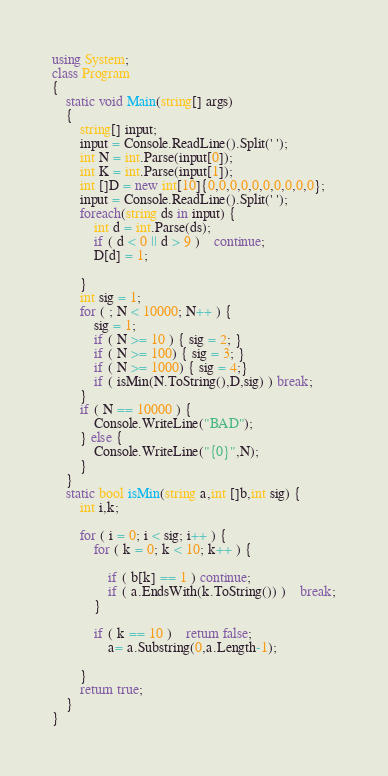<code> <loc_0><loc_0><loc_500><loc_500><_C#_>using System;
class Program
{
	static void Main(string[] args)
	{
		string[] input;
		input = Console.ReadLine().Split(' ');
		int N = int.Parse(input[0]);
		int K = int.Parse(input[1]);
		int []D = new int[10]{0,0,0,0,0,0,0,0,0,0};
		input = Console.ReadLine().Split(' ');
		foreach(string ds in input) {
			int d = int.Parse(ds);
			if ( d < 0 || d > 9 )	continue;
			D[d] = 1;

		}
		int sig = 1;
		for ( ; N < 10000; N++ ) {
			sig = 1;
			if ( N >= 10 ) { sig = 2; }
			if ( N >= 100) { sig = 3; }	
			if ( N >= 1000) { sig = 4;}
			if ( isMin(N.ToString(),D,sig) ) break;
		}
		if ( N == 10000 ) {
			Console.WriteLine("BAD");
		} else {
			Console.WriteLine("{0}",N);
		}
	}
	static bool isMin(string a,int []b,int sig) {
		int i,k;

		for ( i = 0; i < sig; i++ ) {
			for ( k = 0; k < 10; k++ ) {

				if ( b[k] == 1 ) continue;
				if ( a.EndsWith(k.ToString()) )	break;
			}

			if ( k == 10 )	return false;
				a= a.Substring(0,a.Length-1);
			
		}
		return true;
	}
}</code> 